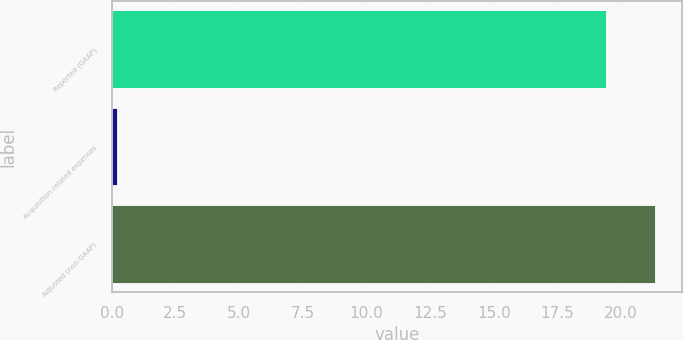Convert chart. <chart><loc_0><loc_0><loc_500><loc_500><bar_chart><fcel>Reported (GAAP)<fcel>Acquisition-related expenses<fcel>Adjusted (non-GAAP)<nl><fcel>19.4<fcel>0.2<fcel>21.34<nl></chart> 